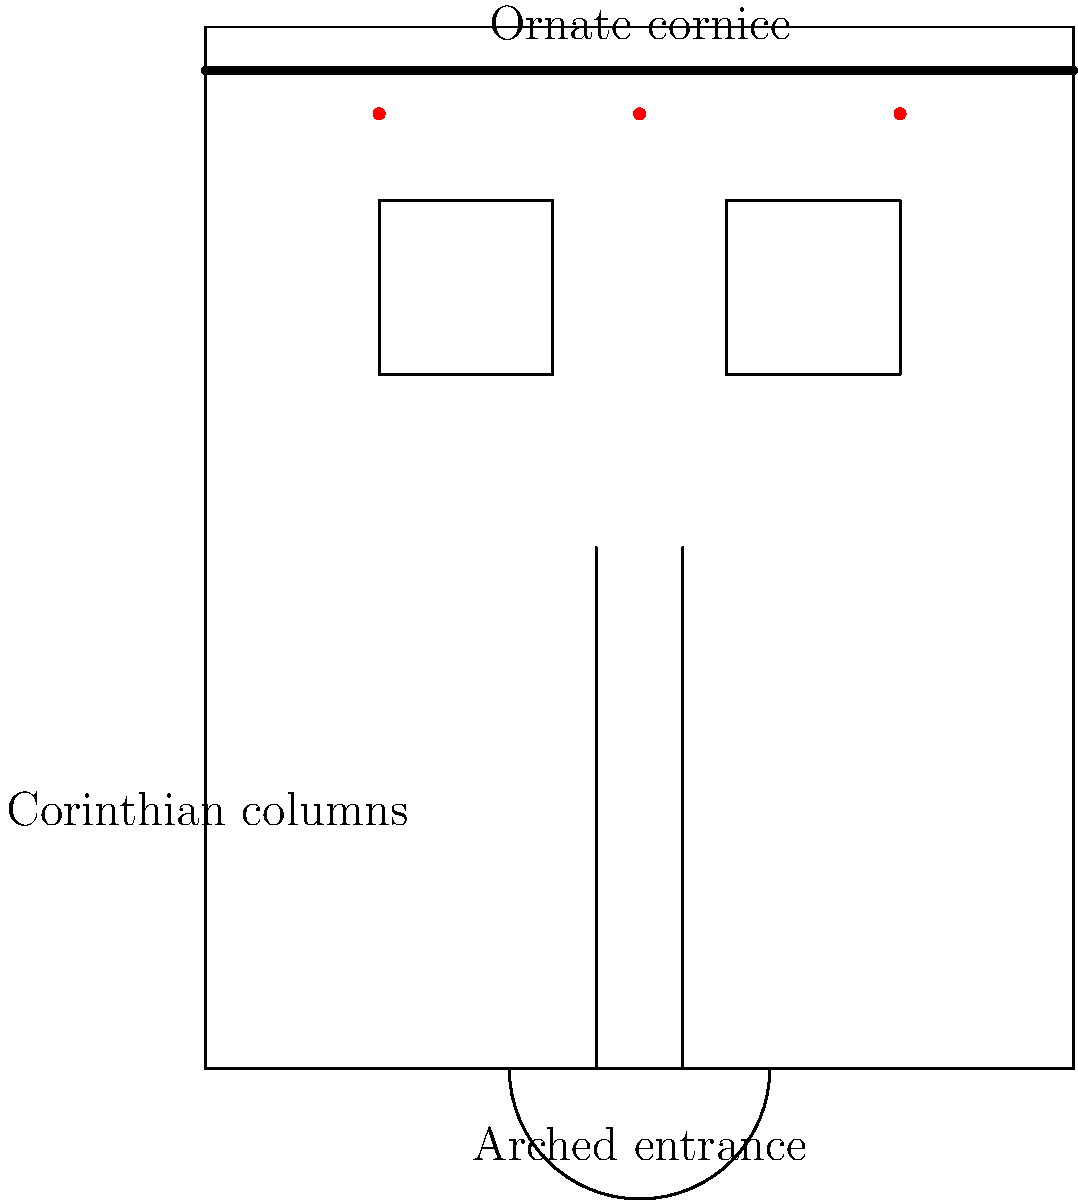Based on the architectural elements shown in the facade sketch, which classical architectural style does this building most likely represent? To identify the architectural style, let's analyze the key elements in the sketch:

1. Symmetry: The facade shows a symmetrical arrangement, which is common in classical architecture.

2. Arched entrance: The central arched doorway is a characteristic feature of many classical styles.

3. Corinthian columns: The presence of Corinthian columns, known for their ornate capitals with acanthus leaves, is a strong indicator of classical influence.

4. Ornate cornice: The decorated cornice at the top of the facade is typical of classical architecture, particularly in more elaborate styles.

5. Rectangular windows: The simple, rectangular windows are consistent with classical designs.

6. Decorative elements: The dots above the cornice suggest additional ornamental details, which are common in more elaborate classical styles.

Given these elements, particularly the combination of Corinthian columns, the ornate cornice, and the overall grandeur of the facade, this building most closely resembles the Neoclassical style. Neoclassicism was a revival of Greek and Roman architecture that began in the mid-18th century and continued into the 19th century. It emphasized symmetry, grandeur, and classical elements like columns and pediments.

While other classical styles (such as Greek Revival or Roman Revival) share some of these features, the combination of the ornate Corinthian order with the overall richness of decoration points most strongly to Neoclassicism.
Answer: Neoclassical 